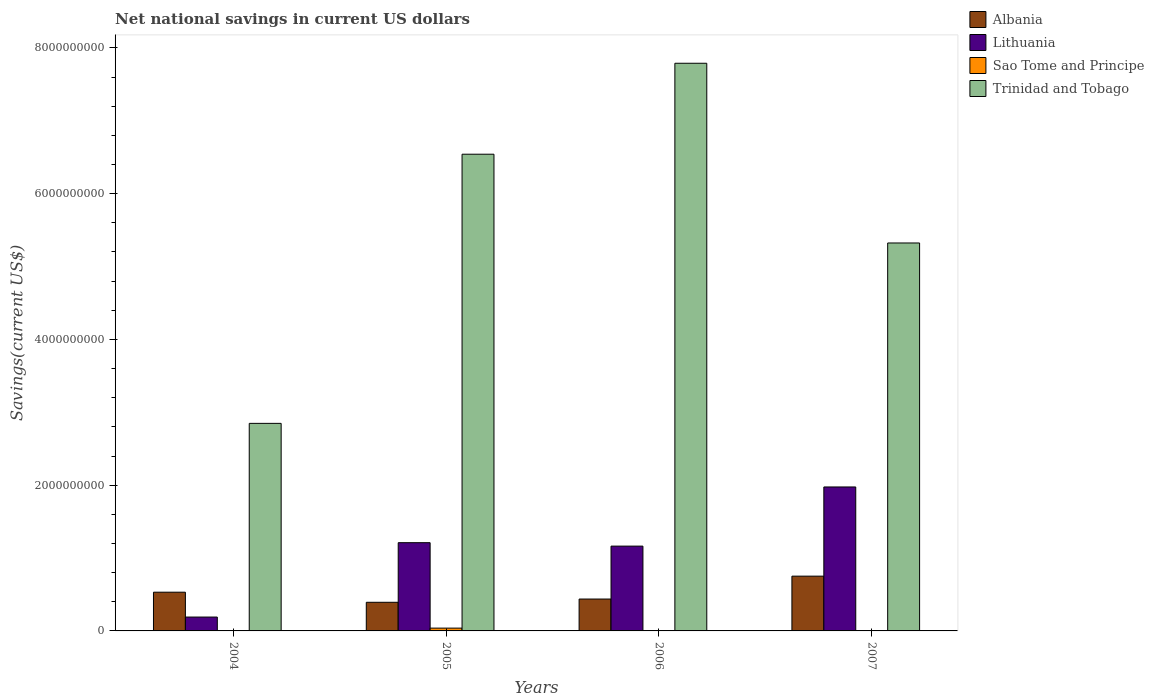How many groups of bars are there?
Your response must be concise. 4. Are the number of bars per tick equal to the number of legend labels?
Keep it short and to the point. No. Are the number of bars on each tick of the X-axis equal?
Ensure brevity in your answer.  No. What is the net national savings in Lithuania in 2007?
Offer a very short reply. 1.98e+09. Across all years, what is the maximum net national savings in Sao Tome and Principe?
Give a very brief answer. 3.84e+07. Across all years, what is the minimum net national savings in Lithuania?
Your answer should be compact. 1.90e+08. What is the total net national savings in Lithuania in the graph?
Your answer should be compact. 4.54e+09. What is the difference between the net national savings in Trinidad and Tobago in 2004 and that in 2007?
Offer a very short reply. -2.48e+09. What is the difference between the net national savings in Lithuania in 2005 and the net national savings in Sao Tome and Principe in 2004?
Your answer should be compact. 1.21e+09. What is the average net national savings in Lithuania per year?
Provide a short and direct response. 1.14e+09. In the year 2005, what is the difference between the net national savings in Sao Tome and Principe and net national savings in Trinidad and Tobago?
Provide a short and direct response. -6.50e+09. In how many years, is the net national savings in Lithuania greater than 4800000000 US$?
Make the answer very short. 0. What is the ratio of the net national savings in Trinidad and Tobago in 2004 to that in 2007?
Give a very brief answer. 0.54. Is the net national savings in Lithuania in 2004 less than that in 2005?
Keep it short and to the point. Yes. What is the difference between the highest and the second highest net national savings in Trinidad and Tobago?
Your response must be concise. 1.25e+09. What is the difference between the highest and the lowest net national savings in Trinidad and Tobago?
Make the answer very short. 4.94e+09. Is the sum of the net national savings in Albania in 2006 and 2007 greater than the maximum net national savings in Sao Tome and Principe across all years?
Provide a short and direct response. Yes. Is it the case that in every year, the sum of the net national savings in Lithuania and net national savings in Sao Tome and Principe is greater than the sum of net national savings in Albania and net national savings in Trinidad and Tobago?
Your answer should be compact. No. Is it the case that in every year, the sum of the net national savings in Lithuania and net national savings in Sao Tome and Principe is greater than the net national savings in Albania?
Offer a very short reply. No. How many years are there in the graph?
Offer a very short reply. 4. How many legend labels are there?
Your answer should be very brief. 4. How are the legend labels stacked?
Provide a succinct answer. Vertical. What is the title of the graph?
Make the answer very short. Net national savings in current US dollars. What is the label or title of the X-axis?
Give a very brief answer. Years. What is the label or title of the Y-axis?
Make the answer very short. Savings(current US$). What is the Savings(current US$) of Albania in 2004?
Make the answer very short. 5.31e+08. What is the Savings(current US$) of Lithuania in 2004?
Your answer should be very brief. 1.90e+08. What is the Savings(current US$) of Sao Tome and Principe in 2004?
Offer a very short reply. 0. What is the Savings(current US$) of Trinidad and Tobago in 2004?
Offer a very short reply. 2.85e+09. What is the Savings(current US$) in Albania in 2005?
Your answer should be compact. 3.93e+08. What is the Savings(current US$) of Lithuania in 2005?
Your response must be concise. 1.21e+09. What is the Savings(current US$) in Sao Tome and Principe in 2005?
Provide a short and direct response. 3.84e+07. What is the Savings(current US$) in Trinidad and Tobago in 2005?
Your response must be concise. 6.54e+09. What is the Savings(current US$) of Albania in 2006?
Provide a short and direct response. 4.37e+08. What is the Savings(current US$) in Lithuania in 2006?
Your answer should be very brief. 1.16e+09. What is the Savings(current US$) in Sao Tome and Principe in 2006?
Provide a short and direct response. 0. What is the Savings(current US$) of Trinidad and Tobago in 2006?
Provide a succinct answer. 7.79e+09. What is the Savings(current US$) in Albania in 2007?
Provide a succinct answer. 7.51e+08. What is the Savings(current US$) of Lithuania in 2007?
Give a very brief answer. 1.98e+09. What is the Savings(current US$) in Sao Tome and Principe in 2007?
Offer a very short reply. 0. What is the Savings(current US$) of Trinidad and Tobago in 2007?
Your answer should be compact. 5.32e+09. Across all years, what is the maximum Savings(current US$) in Albania?
Offer a terse response. 7.51e+08. Across all years, what is the maximum Savings(current US$) in Lithuania?
Provide a succinct answer. 1.98e+09. Across all years, what is the maximum Savings(current US$) of Sao Tome and Principe?
Provide a succinct answer. 3.84e+07. Across all years, what is the maximum Savings(current US$) of Trinidad and Tobago?
Give a very brief answer. 7.79e+09. Across all years, what is the minimum Savings(current US$) of Albania?
Provide a short and direct response. 3.93e+08. Across all years, what is the minimum Savings(current US$) of Lithuania?
Your answer should be very brief. 1.90e+08. Across all years, what is the minimum Savings(current US$) of Sao Tome and Principe?
Give a very brief answer. 0. Across all years, what is the minimum Savings(current US$) in Trinidad and Tobago?
Your response must be concise. 2.85e+09. What is the total Savings(current US$) of Albania in the graph?
Your answer should be very brief. 2.11e+09. What is the total Savings(current US$) in Lithuania in the graph?
Offer a terse response. 4.54e+09. What is the total Savings(current US$) of Sao Tome and Principe in the graph?
Your response must be concise. 3.84e+07. What is the total Savings(current US$) in Trinidad and Tobago in the graph?
Offer a very short reply. 2.25e+1. What is the difference between the Savings(current US$) of Albania in 2004 and that in 2005?
Make the answer very short. 1.38e+08. What is the difference between the Savings(current US$) of Lithuania in 2004 and that in 2005?
Offer a terse response. -1.02e+09. What is the difference between the Savings(current US$) in Trinidad and Tobago in 2004 and that in 2005?
Provide a succinct answer. -3.69e+09. What is the difference between the Savings(current US$) in Albania in 2004 and that in 2006?
Your response must be concise. 9.39e+07. What is the difference between the Savings(current US$) in Lithuania in 2004 and that in 2006?
Make the answer very short. -9.73e+08. What is the difference between the Savings(current US$) of Trinidad and Tobago in 2004 and that in 2006?
Your answer should be compact. -4.94e+09. What is the difference between the Savings(current US$) of Albania in 2004 and that in 2007?
Ensure brevity in your answer.  -2.20e+08. What is the difference between the Savings(current US$) of Lithuania in 2004 and that in 2007?
Provide a short and direct response. -1.79e+09. What is the difference between the Savings(current US$) in Trinidad and Tobago in 2004 and that in 2007?
Make the answer very short. -2.48e+09. What is the difference between the Savings(current US$) of Albania in 2005 and that in 2006?
Offer a terse response. -4.45e+07. What is the difference between the Savings(current US$) in Lithuania in 2005 and that in 2006?
Ensure brevity in your answer.  4.73e+07. What is the difference between the Savings(current US$) in Trinidad and Tobago in 2005 and that in 2006?
Give a very brief answer. -1.25e+09. What is the difference between the Savings(current US$) of Albania in 2005 and that in 2007?
Your response must be concise. -3.59e+08. What is the difference between the Savings(current US$) of Lithuania in 2005 and that in 2007?
Ensure brevity in your answer.  -7.64e+08. What is the difference between the Savings(current US$) of Trinidad and Tobago in 2005 and that in 2007?
Provide a succinct answer. 1.22e+09. What is the difference between the Savings(current US$) of Albania in 2006 and that in 2007?
Offer a very short reply. -3.14e+08. What is the difference between the Savings(current US$) in Lithuania in 2006 and that in 2007?
Provide a succinct answer. -8.12e+08. What is the difference between the Savings(current US$) in Trinidad and Tobago in 2006 and that in 2007?
Keep it short and to the point. 2.47e+09. What is the difference between the Savings(current US$) of Albania in 2004 and the Savings(current US$) of Lithuania in 2005?
Your response must be concise. -6.79e+08. What is the difference between the Savings(current US$) in Albania in 2004 and the Savings(current US$) in Sao Tome and Principe in 2005?
Give a very brief answer. 4.93e+08. What is the difference between the Savings(current US$) of Albania in 2004 and the Savings(current US$) of Trinidad and Tobago in 2005?
Your answer should be very brief. -6.01e+09. What is the difference between the Savings(current US$) of Lithuania in 2004 and the Savings(current US$) of Sao Tome and Principe in 2005?
Offer a terse response. 1.52e+08. What is the difference between the Savings(current US$) in Lithuania in 2004 and the Savings(current US$) in Trinidad and Tobago in 2005?
Ensure brevity in your answer.  -6.35e+09. What is the difference between the Savings(current US$) of Albania in 2004 and the Savings(current US$) of Lithuania in 2006?
Keep it short and to the point. -6.32e+08. What is the difference between the Savings(current US$) of Albania in 2004 and the Savings(current US$) of Trinidad and Tobago in 2006?
Make the answer very short. -7.26e+09. What is the difference between the Savings(current US$) of Lithuania in 2004 and the Savings(current US$) of Trinidad and Tobago in 2006?
Give a very brief answer. -7.60e+09. What is the difference between the Savings(current US$) in Albania in 2004 and the Savings(current US$) in Lithuania in 2007?
Your response must be concise. -1.44e+09. What is the difference between the Savings(current US$) of Albania in 2004 and the Savings(current US$) of Trinidad and Tobago in 2007?
Your answer should be very brief. -4.79e+09. What is the difference between the Savings(current US$) in Lithuania in 2004 and the Savings(current US$) in Trinidad and Tobago in 2007?
Make the answer very short. -5.13e+09. What is the difference between the Savings(current US$) in Albania in 2005 and the Savings(current US$) in Lithuania in 2006?
Your answer should be very brief. -7.71e+08. What is the difference between the Savings(current US$) in Albania in 2005 and the Savings(current US$) in Trinidad and Tobago in 2006?
Your answer should be very brief. -7.40e+09. What is the difference between the Savings(current US$) in Lithuania in 2005 and the Savings(current US$) in Trinidad and Tobago in 2006?
Your answer should be compact. -6.58e+09. What is the difference between the Savings(current US$) in Sao Tome and Principe in 2005 and the Savings(current US$) in Trinidad and Tobago in 2006?
Ensure brevity in your answer.  -7.75e+09. What is the difference between the Savings(current US$) of Albania in 2005 and the Savings(current US$) of Lithuania in 2007?
Ensure brevity in your answer.  -1.58e+09. What is the difference between the Savings(current US$) in Albania in 2005 and the Savings(current US$) in Trinidad and Tobago in 2007?
Provide a short and direct response. -4.93e+09. What is the difference between the Savings(current US$) in Lithuania in 2005 and the Savings(current US$) in Trinidad and Tobago in 2007?
Offer a very short reply. -4.11e+09. What is the difference between the Savings(current US$) in Sao Tome and Principe in 2005 and the Savings(current US$) in Trinidad and Tobago in 2007?
Your answer should be compact. -5.28e+09. What is the difference between the Savings(current US$) of Albania in 2006 and the Savings(current US$) of Lithuania in 2007?
Keep it short and to the point. -1.54e+09. What is the difference between the Savings(current US$) of Albania in 2006 and the Savings(current US$) of Trinidad and Tobago in 2007?
Provide a succinct answer. -4.89e+09. What is the difference between the Savings(current US$) of Lithuania in 2006 and the Savings(current US$) of Trinidad and Tobago in 2007?
Ensure brevity in your answer.  -4.16e+09. What is the average Savings(current US$) of Albania per year?
Ensure brevity in your answer.  5.28e+08. What is the average Savings(current US$) in Lithuania per year?
Make the answer very short. 1.14e+09. What is the average Savings(current US$) in Sao Tome and Principe per year?
Your answer should be compact. 9.60e+06. What is the average Savings(current US$) in Trinidad and Tobago per year?
Offer a very short reply. 5.63e+09. In the year 2004, what is the difference between the Savings(current US$) in Albania and Savings(current US$) in Lithuania?
Provide a short and direct response. 3.41e+08. In the year 2004, what is the difference between the Savings(current US$) in Albania and Savings(current US$) in Trinidad and Tobago?
Your answer should be compact. -2.32e+09. In the year 2004, what is the difference between the Savings(current US$) in Lithuania and Savings(current US$) in Trinidad and Tobago?
Your answer should be compact. -2.66e+09. In the year 2005, what is the difference between the Savings(current US$) in Albania and Savings(current US$) in Lithuania?
Give a very brief answer. -8.18e+08. In the year 2005, what is the difference between the Savings(current US$) of Albania and Savings(current US$) of Sao Tome and Principe?
Provide a succinct answer. 3.55e+08. In the year 2005, what is the difference between the Savings(current US$) in Albania and Savings(current US$) in Trinidad and Tobago?
Your answer should be very brief. -6.15e+09. In the year 2005, what is the difference between the Savings(current US$) in Lithuania and Savings(current US$) in Sao Tome and Principe?
Give a very brief answer. 1.17e+09. In the year 2005, what is the difference between the Savings(current US$) of Lithuania and Savings(current US$) of Trinidad and Tobago?
Provide a short and direct response. -5.33e+09. In the year 2005, what is the difference between the Savings(current US$) of Sao Tome and Principe and Savings(current US$) of Trinidad and Tobago?
Offer a very short reply. -6.50e+09. In the year 2006, what is the difference between the Savings(current US$) in Albania and Savings(current US$) in Lithuania?
Provide a succinct answer. -7.26e+08. In the year 2006, what is the difference between the Savings(current US$) in Albania and Savings(current US$) in Trinidad and Tobago?
Your response must be concise. -7.35e+09. In the year 2006, what is the difference between the Savings(current US$) of Lithuania and Savings(current US$) of Trinidad and Tobago?
Provide a succinct answer. -6.63e+09. In the year 2007, what is the difference between the Savings(current US$) of Albania and Savings(current US$) of Lithuania?
Ensure brevity in your answer.  -1.22e+09. In the year 2007, what is the difference between the Savings(current US$) in Albania and Savings(current US$) in Trinidad and Tobago?
Your response must be concise. -4.57e+09. In the year 2007, what is the difference between the Savings(current US$) of Lithuania and Savings(current US$) of Trinidad and Tobago?
Your answer should be compact. -3.35e+09. What is the ratio of the Savings(current US$) in Albania in 2004 to that in 2005?
Give a very brief answer. 1.35. What is the ratio of the Savings(current US$) in Lithuania in 2004 to that in 2005?
Offer a very short reply. 0.16. What is the ratio of the Savings(current US$) of Trinidad and Tobago in 2004 to that in 2005?
Your response must be concise. 0.44. What is the ratio of the Savings(current US$) of Albania in 2004 to that in 2006?
Your answer should be very brief. 1.21. What is the ratio of the Savings(current US$) in Lithuania in 2004 to that in 2006?
Your answer should be compact. 0.16. What is the ratio of the Savings(current US$) in Trinidad and Tobago in 2004 to that in 2006?
Your response must be concise. 0.37. What is the ratio of the Savings(current US$) of Albania in 2004 to that in 2007?
Give a very brief answer. 0.71. What is the ratio of the Savings(current US$) of Lithuania in 2004 to that in 2007?
Offer a terse response. 0.1. What is the ratio of the Savings(current US$) of Trinidad and Tobago in 2004 to that in 2007?
Keep it short and to the point. 0.54. What is the ratio of the Savings(current US$) in Albania in 2005 to that in 2006?
Your answer should be very brief. 0.9. What is the ratio of the Savings(current US$) in Lithuania in 2005 to that in 2006?
Make the answer very short. 1.04. What is the ratio of the Savings(current US$) of Trinidad and Tobago in 2005 to that in 2006?
Your response must be concise. 0.84. What is the ratio of the Savings(current US$) of Albania in 2005 to that in 2007?
Ensure brevity in your answer.  0.52. What is the ratio of the Savings(current US$) of Lithuania in 2005 to that in 2007?
Your answer should be compact. 0.61. What is the ratio of the Savings(current US$) in Trinidad and Tobago in 2005 to that in 2007?
Offer a terse response. 1.23. What is the ratio of the Savings(current US$) of Albania in 2006 to that in 2007?
Provide a succinct answer. 0.58. What is the ratio of the Savings(current US$) in Lithuania in 2006 to that in 2007?
Offer a terse response. 0.59. What is the ratio of the Savings(current US$) in Trinidad and Tobago in 2006 to that in 2007?
Keep it short and to the point. 1.46. What is the difference between the highest and the second highest Savings(current US$) in Albania?
Offer a very short reply. 2.20e+08. What is the difference between the highest and the second highest Savings(current US$) in Lithuania?
Give a very brief answer. 7.64e+08. What is the difference between the highest and the second highest Savings(current US$) of Trinidad and Tobago?
Keep it short and to the point. 1.25e+09. What is the difference between the highest and the lowest Savings(current US$) in Albania?
Ensure brevity in your answer.  3.59e+08. What is the difference between the highest and the lowest Savings(current US$) in Lithuania?
Keep it short and to the point. 1.79e+09. What is the difference between the highest and the lowest Savings(current US$) of Sao Tome and Principe?
Your answer should be very brief. 3.84e+07. What is the difference between the highest and the lowest Savings(current US$) of Trinidad and Tobago?
Give a very brief answer. 4.94e+09. 